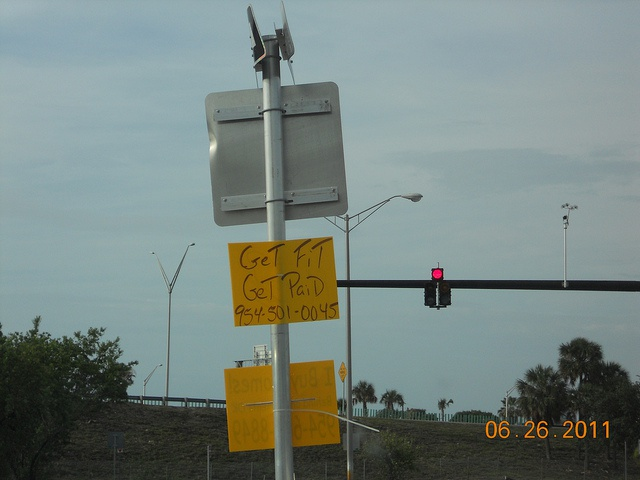Describe the objects in this image and their specific colors. I can see a traffic light in darkgray, black, gray, and salmon tones in this image. 